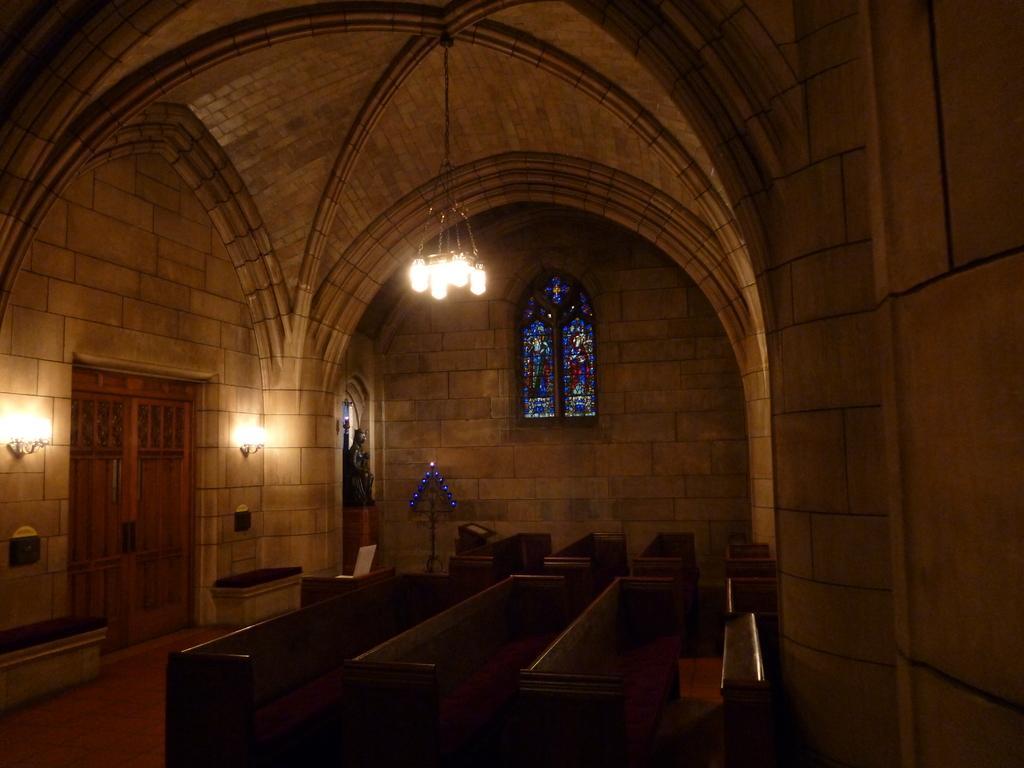Can you describe this image briefly? In this picture we can see benches on the floor, doors, lights, walls, statue, ceiling and some objects and in the background we can see a window. 